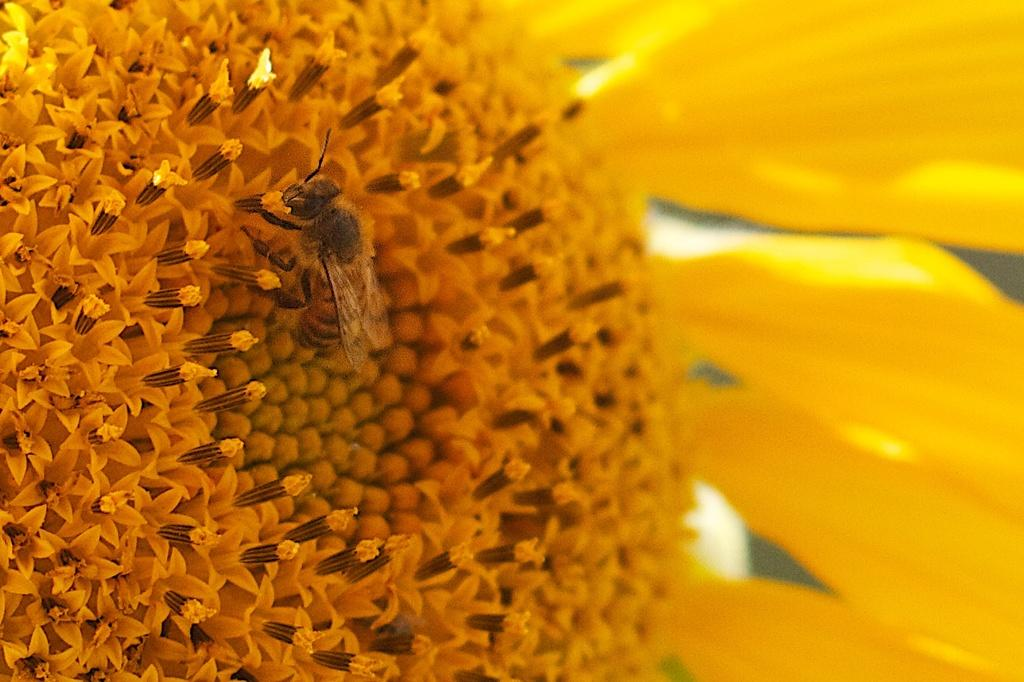What type of creature is in the image? There is an insect in the image. What features does the insect have? The insect has wings and legs. What is the insect standing on in the image? The insect is standing on a yellow flower. What can be said about the appearance of the yellow flower? The yellow flower has yellow petals. What type of music can be heard coming from the insect in the image? There is no indication in the image that the insect is making any sounds, let alone music. 